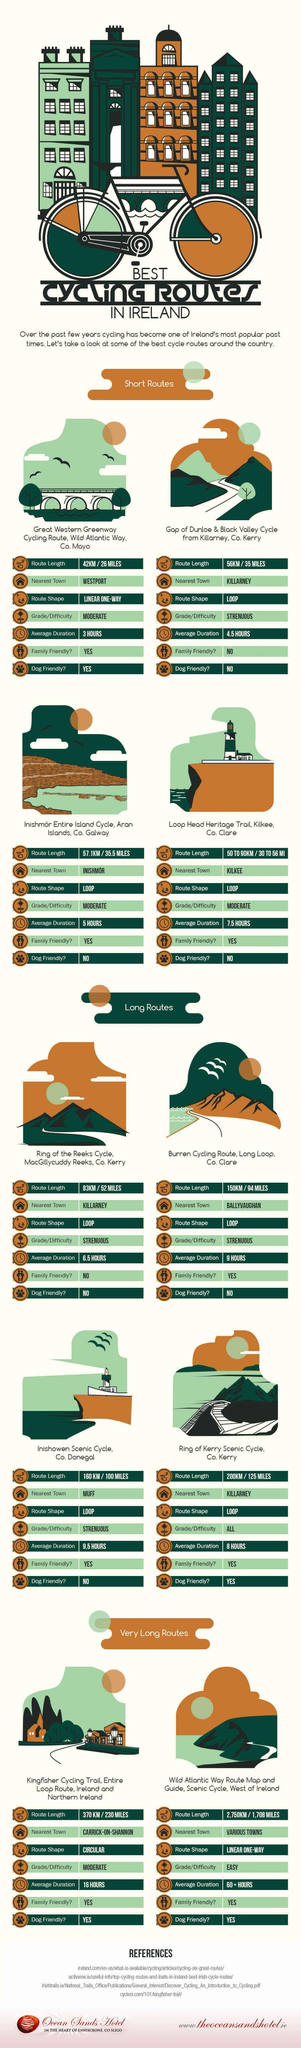Which route is not family friendly in the short routes?
Answer the question with a short phrase. Gap of Dunloe & Black Valley How many dog friendly route are there in total? 4 What is the route shape in long routes? LOOP Which short cycling route is dog friendly? Great Western Greenway Cycling Route Which long cycling route takes 9.5 hours to complete? Inishowen Scenic cycle What is the shortest length one can cycle in the long cycling routes? 83KM / 52 MILES What is the longest length one can cycle in the short cycling routes? 50 TO 90KM / 30 TO 56 MI What is the average time required to complete the Loop head Heritage trail, 3 hours, 5 hours, or 7.5 hours? 7.5 hours How many short routes have moderate difficulty levels while cycling? 3 What is the longest time taken to complete the longest route in Ireland ? 60+ Hours 